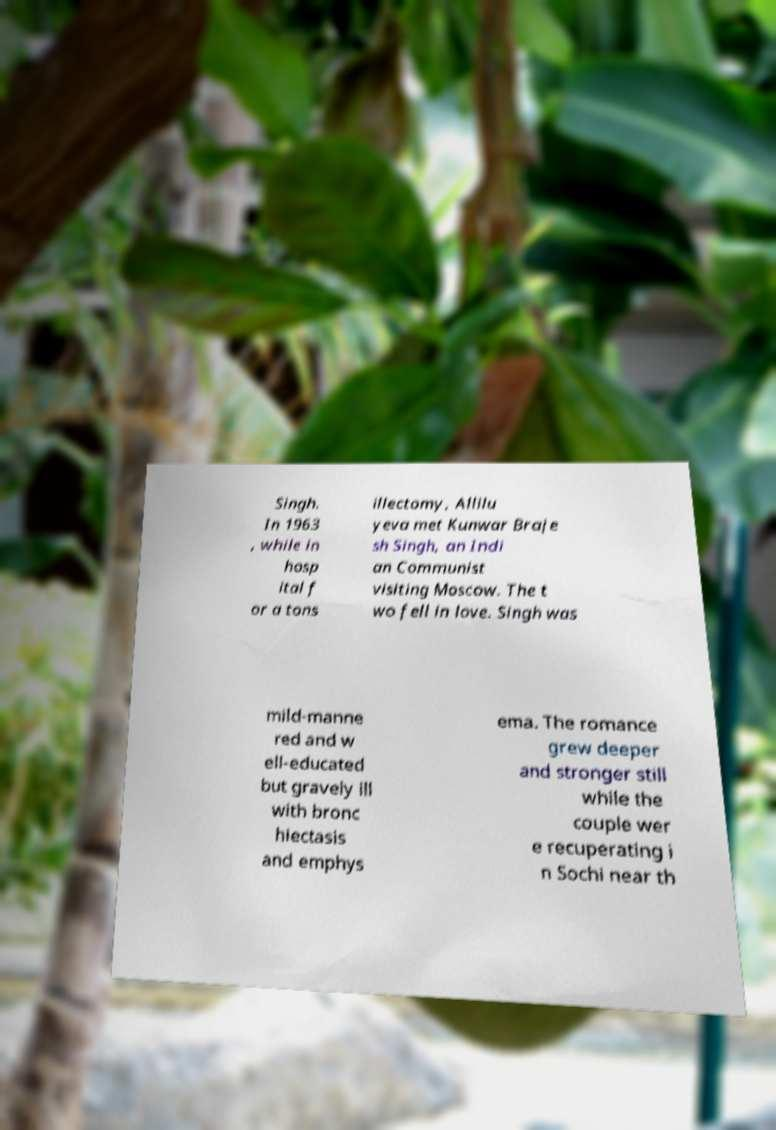Could you extract and type out the text from this image? Singh. In 1963 , while in hosp ital f or a tons illectomy, Allilu yeva met Kunwar Braje sh Singh, an Indi an Communist visiting Moscow. The t wo fell in love. Singh was mild-manne red and w ell-educated but gravely ill with bronc hiectasis and emphys ema. The romance grew deeper and stronger still while the couple wer e recuperating i n Sochi near th 